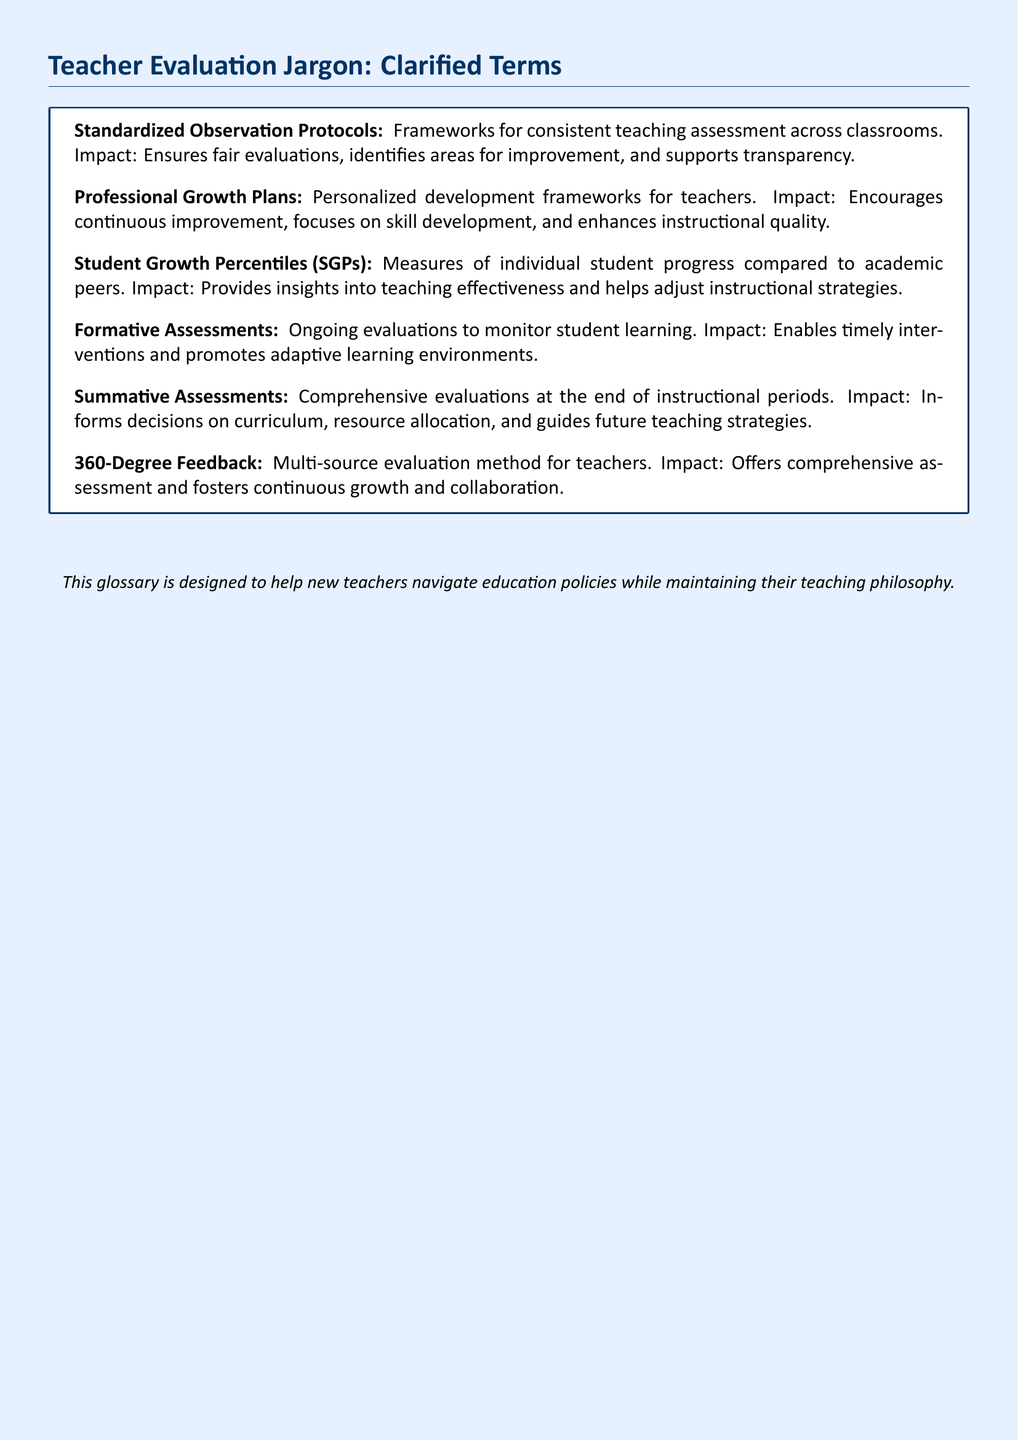What is the purpose of Standardized Observation Protocols? They are frameworks for consistent teaching assessment across classrooms, ensuring fair evaluations.
Answer: Fair evaluations What do Professional Growth Plans focus on? They are personalized development frameworks for teachers focusing on continuous improvement and skill development.
Answer: Skill development What is measured by Student Growth Percentiles? They measure individual student progress compared to academic peers, providing insights into teaching effectiveness.
Answer: Individual student progress What type of assessments are ongoing evaluations? Ongoing evaluations to monitor student learning are called formative assessments.
Answer: Formative assessments What is the impact of Summative Assessments? They inform decisions on curriculum, resource allocation, and guide future teaching strategies at the end of instructional periods.
Answer: Inform decisions What does 360-Degree Feedback involve? It is a multi-source evaluation method for teachers that offers comprehensive assessment.
Answer: Multi-source evaluation What is the impact of formative assessments? They enable timely interventions and promote adaptive learning environments.
Answer: Timely interventions How does Student Growth Percentiles help teachers? They help adjust instructional strategies by providing insights into teaching effectiveness.
Answer: Adjust instructional strategies 